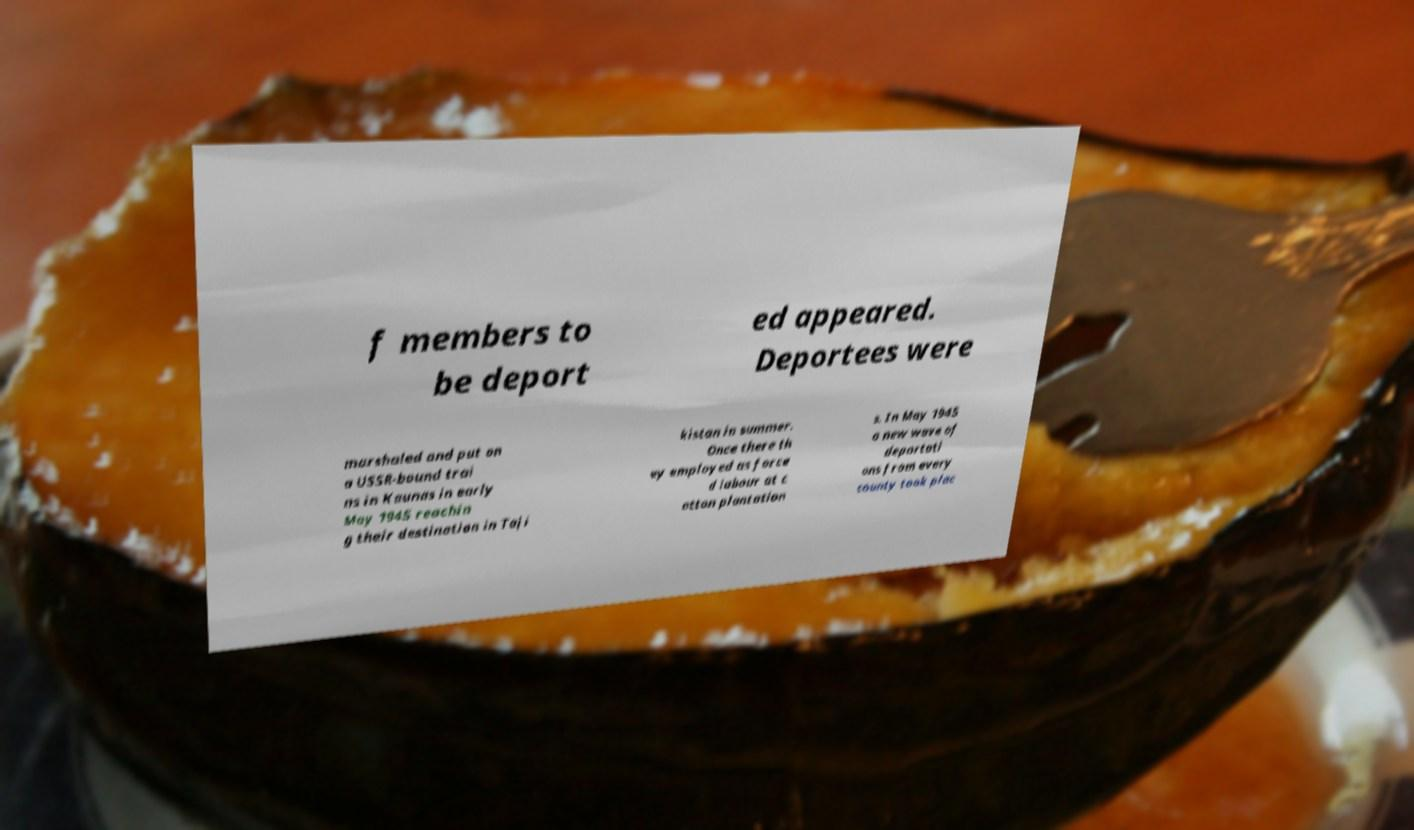Please identify and transcribe the text found in this image. f members to be deport ed appeared. Deportees were marshaled and put on a USSR-bound trai ns in Kaunas in early May 1945 reachin g their destination in Taji kistan in summer. Once there th ey employed as force d labour at c otton plantation s. In May 1945 a new wave of deportati ons from every county took plac 